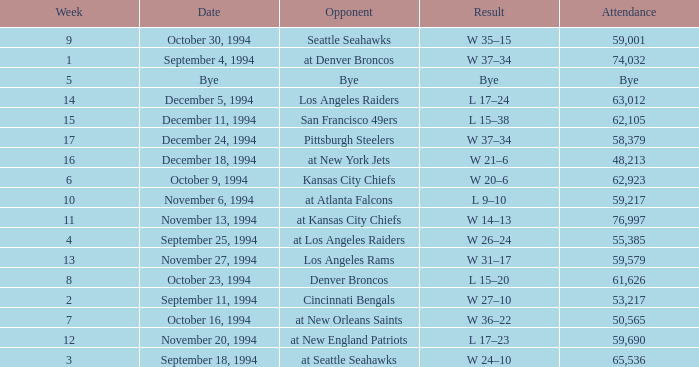On November 20, 1994, what was the result of the game? L 17–23. 